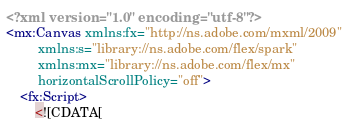Convert code to text. <code><loc_0><loc_0><loc_500><loc_500><_XML_><?xml version="1.0" encoding="utf-8"?>
<mx:Canvas xmlns:fx="http://ns.adobe.com/mxml/2009" 
		 xmlns:s="library://ns.adobe.com/flex/spark" 
		 xmlns:mx="library://ns.adobe.com/flex/mx"
		 horizontalScrollPolicy="off">
	<fx:Script>
		<![CDATA[</code> 